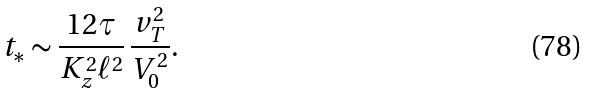<formula> <loc_0><loc_0><loc_500><loc_500>t _ { * } \sim \frac { 1 2 \tau } { K _ { z } ^ { 2 } \ell ^ { 2 } } \, \frac { v _ { T } ^ { 2 } } { V _ { 0 } ^ { 2 } } .</formula> 